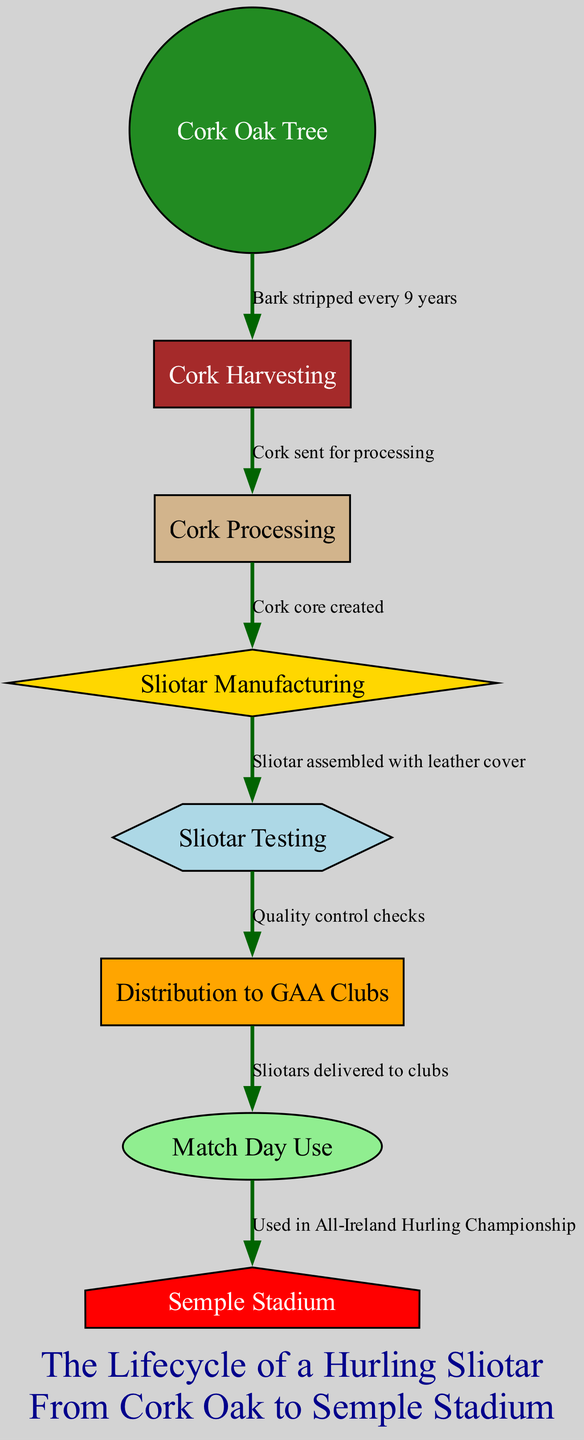What is the first node in the lifecycle of a hurling sliotar? The diagram starts with the "Cork Oak Tree" as the first node, indicating the very beginning of the lifecycle process before any manufacturing occurs.
Answer: Cork Oak Tree How often is cork harvested from a Cork Oak Tree? According to the connections in the diagram, cork is stripped from the tree every 9 years, making this a recurring process in its lifecycle.
Answer: Every 9 years What is created after the cork is processed? After the cork is sent for processing, the next step in the diagram indicates that a "Cork core" is created, which is a vital part for the manufacturing of the sliotar.
Answer: Cork core What type of node represents "Sliotar Testing"? In the diagram, "Sliotar Testing" is represented as a hexagon, which signifies a specific type of process in the lifecycle leading up to the distribution phase.
Answer: Hexagon What is the label connecting "Sliotar Manufacturing" and "Sliotar Testing"? The diagram specifies a connection labeled "Sliotar assembled with leather cover" that indicates the process involved in crafting the sliotar before it is tested for quality.
Answer: Sliotar assembled with leather cover What is the final destination for the sliotars after they are distributed? Based on the diagram, the final destination for the sliotars after distribution is "Semple Stadium," where they are used during matches.
Answer: Semple Stadium How many nodes are there in total in the diagram? By counting the nodes listed in the diagram, there are eight distinct nodes that outline the lifecycle from the Cork Oak Tree to match day use.
Answer: Eight What connects "Match Day Use" and "Semple Stadium"? In the diagram, the connection labeled "Used in All-Ireland Hurling Championship" illustrates the relationship between match day use and the venue of Semple Stadium.
Answer: Used in All-Ireland Hurling Championship 